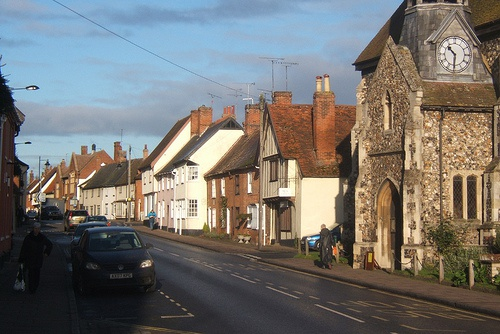Describe the objects in this image and their specific colors. I can see car in darkgray, black, gray, and darkblue tones, people in darkgray, black, and purple tones, clock in darkgray, lightgray, and gray tones, people in darkgray, black, and gray tones, and car in darkgray, black, gray, tan, and maroon tones in this image. 